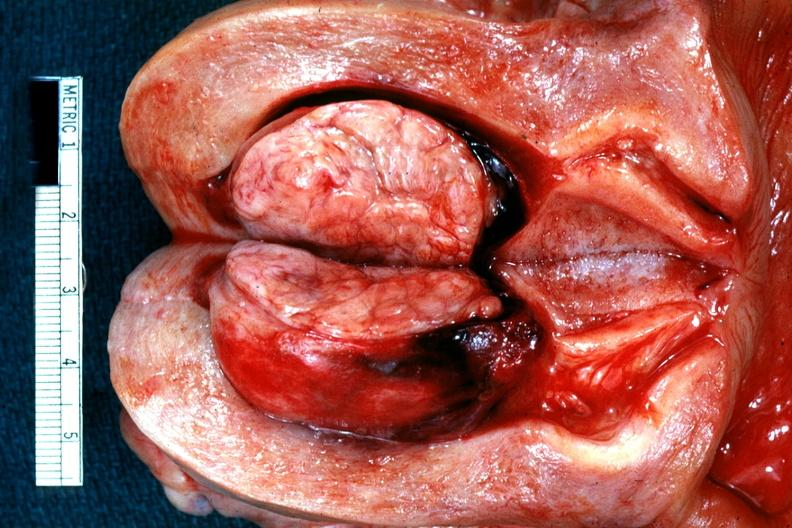what is present?
Answer the question using a single word or phrase. Female reproductive 